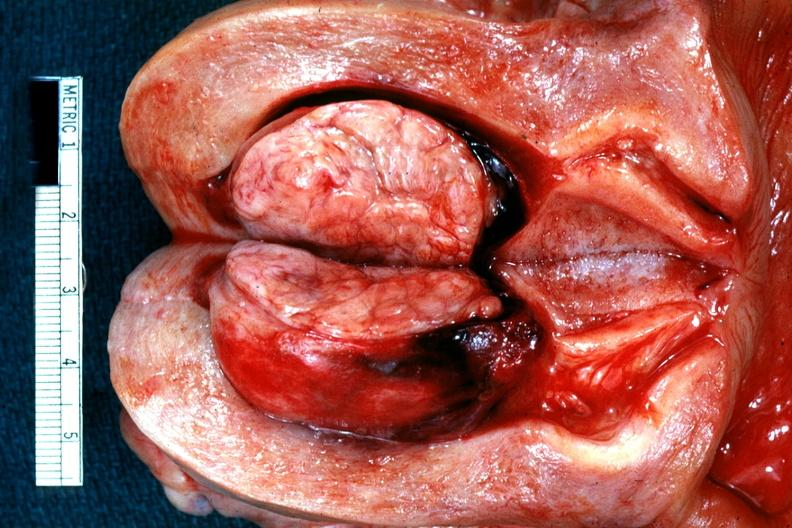what is present?
Answer the question using a single word or phrase. Female reproductive 